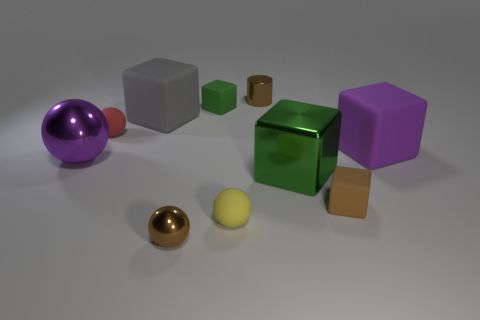Is the shiny cylinder the same color as the tiny metal ball?
Your response must be concise. Yes. Are there any things that have the same color as the large metallic sphere?
Your answer should be compact. Yes. There is a cylinder that is the same size as the red rubber thing; what color is it?
Provide a short and direct response. Brown. There is a cube that is behind the large metal cube and in front of the gray cube; what is its color?
Offer a terse response. Purple. There is a cube that is the same color as the metallic cylinder; what is its size?
Keep it short and to the point. Small. There is a matte thing that is the same color as the tiny metallic cylinder; what is its shape?
Keep it short and to the point. Cube. There is a brown shiny object that is in front of the big matte cube to the right of the green block that is in front of the large gray rubber thing; how big is it?
Make the answer very short. Small. What is the material of the tiny brown cylinder?
Ensure brevity in your answer.  Metal. Does the brown ball have the same material as the purple thing that is to the right of the small red matte thing?
Offer a terse response. No. Is there anything else that is the same color as the cylinder?
Ensure brevity in your answer.  Yes. 